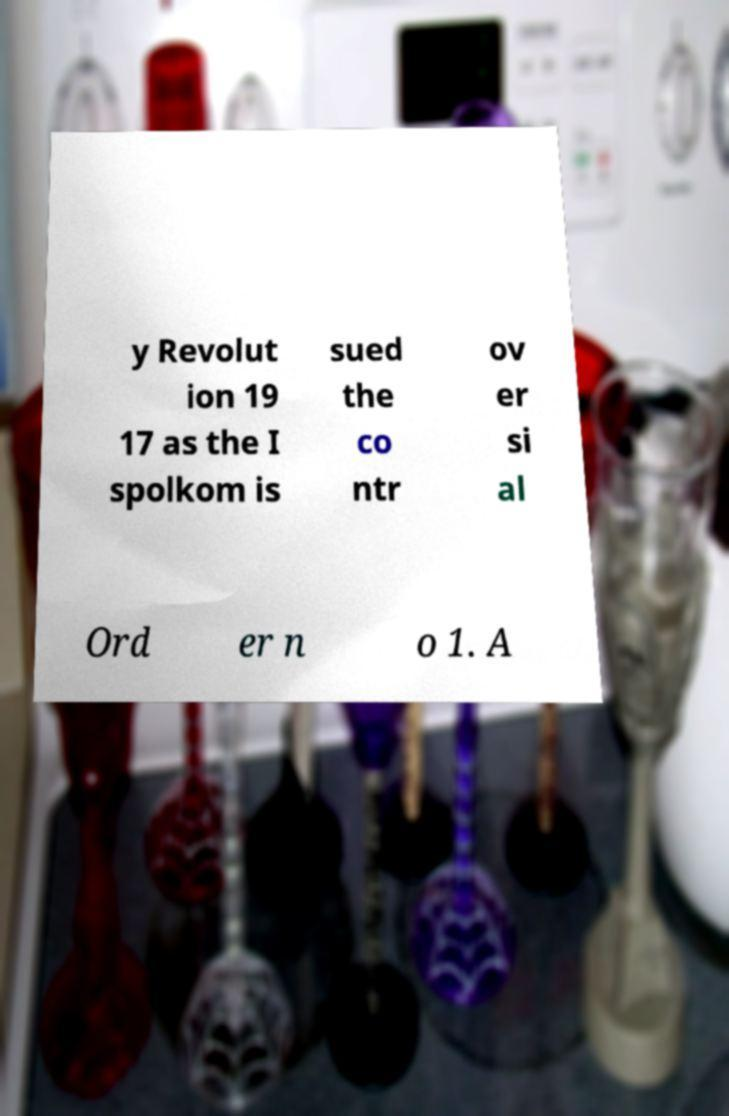Could you extract and type out the text from this image? y Revolut ion 19 17 as the I spolkom is sued the co ntr ov er si al Ord er n o 1. A 